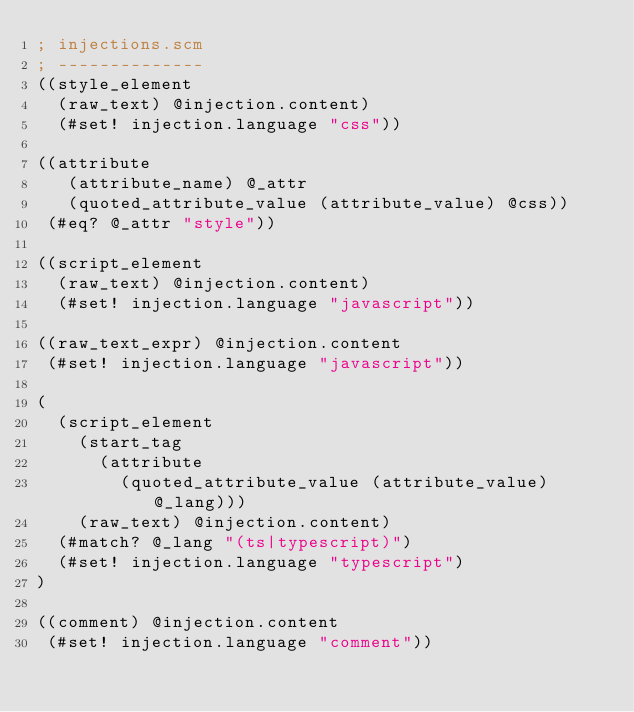<code> <loc_0><loc_0><loc_500><loc_500><_Scheme_>; injections.scm
; --------------
((style_element
  (raw_text) @injection.content)
  (#set! injection.language "css"))

((attribute
   (attribute_name) @_attr
   (quoted_attribute_value (attribute_value) @css))
 (#eq? @_attr "style"))

((script_element
  (raw_text) @injection.content)
  (#set! injection.language "javascript"))

((raw_text_expr) @injection.content
 (#set! injection.language "javascript"))

(
  (script_element
    (start_tag
      (attribute
        (quoted_attribute_value (attribute_value) @_lang)))
    (raw_text) @injection.content)
  (#match? @_lang "(ts|typescript)")
  (#set! injection.language "typescript")
)

((comment) @injection.content
 (#set! injection.language "comment"))
</code> 